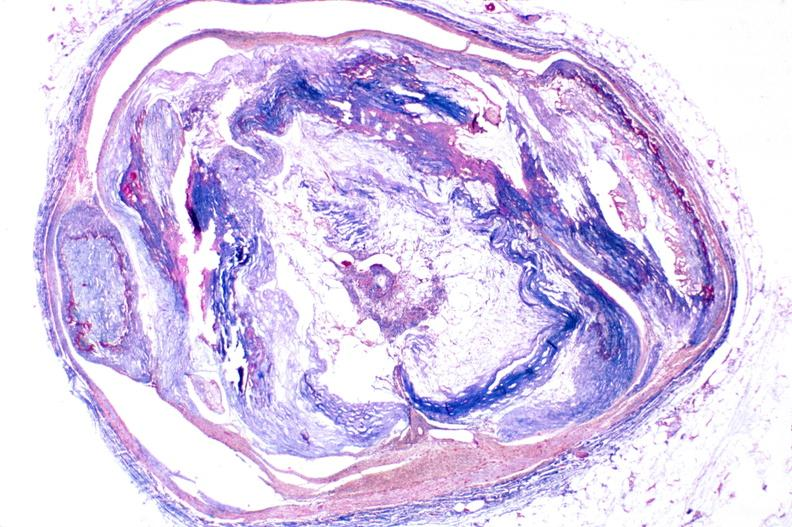s vasculature present?
Answer the question using a single word or phrase. Yes 